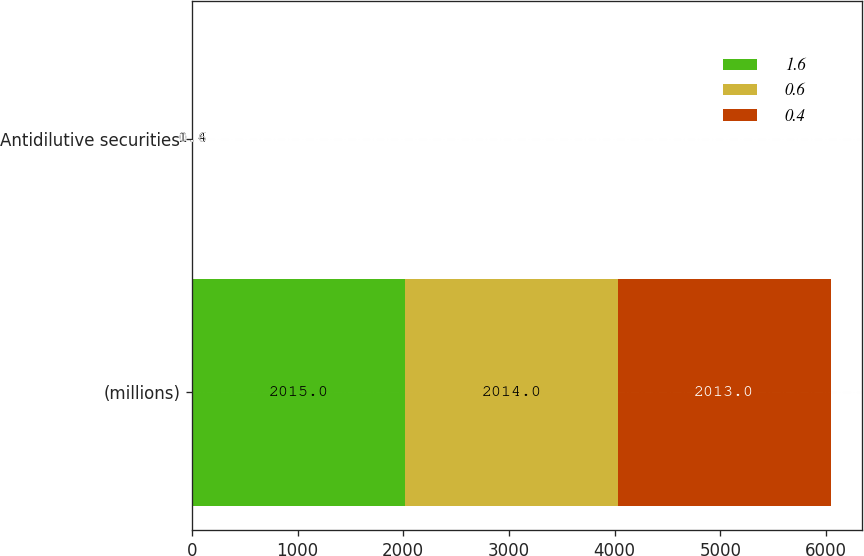Convert chart to OTSL. <chart><loc_0><loc_0><loc_500><loc_500><stacked_bar_chart><ecel><fcel>(millions)<fcel>Antidilutive securities<nl><fcel>1.6<fcel>2015<fcel>0.4<nl><fcel>0.6<fcel>2014<fcel>1.6<nl><fcel>0.4<fcel>2013<fcel>0.6<nl></chart> 